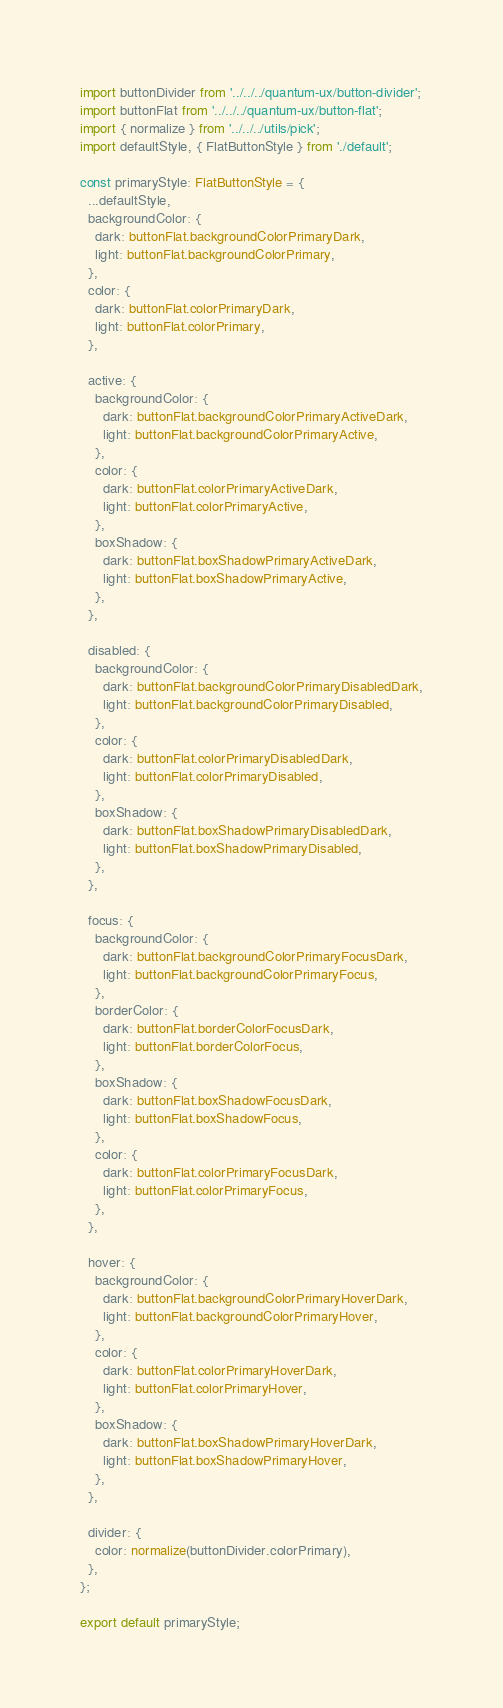<code> <loc_0><loc_0><loc_500><loc_500><_TypeScript_>import buttonDivider from '../../../quantum-ux/button-divider';
import buttonFlat from '../../../quantum-ux/button-flat';
import { normalize } from '../../../utils/pick';
import defaultStyle, { FlatButtonStyle } from './default';

const primaryStyle: FlatButtonStyle = {
  ...defaultStyle,
  backgroundColor: {
    dark: buttonFlat.backgroundColorPrimaryDark,
    light: buttonFlat.backgroundColorPrimary,
  },
  color: {
    dark: buttonFlat.colorPrimaryDark,
    light: buttonFlat.colorPrimary,
  },

  active: {
    backgroundColor: {
      dark: buttonFlat.backgroundColorPrimaryActiveDark,
      light: buttonFlat.backgroundColorPrimaryActive,
    },
    color: {
      dark: buttonFlat.colorPrimaryActiveDark,
      light: buttonFlat.colorPrimaryActive,
    },
    boxShadow: {
      dark: buttonFlat.boxShadowPrimaryActiveDark,
      light: buttonFlat.boxShadowPrimaryActive,
    },
  },

  disabled: {
    backgroundColor: {
      dark: buttonFlat.backgroundColorPrimaryDisabledDark,
      light: buttonFlat.backgroundColorPrimaryDisabled,
    },
    color: {
      dark: buttonFlat.colorPrimaryDisabledDark,
      light: buttonFlat.colorPrimaryDisabled,
    },
    boxShadow: {
      dark: buttonFlat.boxShadowPrimaryDisabledDark,
      light: buttonFlat.boxShadowPrimaryDisabled,
    },
  },

  focus: {
    backgroundColor: {
      dark: buttonFlat.backgroundColorPrimaryFocusDark,
      light: buttonFlat.backgroundColorPrimaryFocus,
    },
    borderColor: {
      dark: buttonFlat.borderColorFocusDark,
      light: buttonFlat.borderColorFocus,
    },
    boxShadow: {
      dark: buttonFlat.boxShadowFocusDark,
      light: buttonFlat.boxShadowFocus,
    },
    color: {
      dark: buttonFlat.colorPrimaryFocusDark,
      light: buttonFlat.colorPrimaryFocus,
    },
  },

  hover: {
    backgroundColor: {
      dark: buttonFlat.backgroundColorPrimaryHoverDark,
      light: buttonFlat.backgroundColorPrimaryHover,
    },
    color: {
      dark: buttonFlat.colorPrimaryHoverDark,
      light: buttonFlat.colorPrimaryHover,
    },
    boxShadow: {
      dark: buttonFlat.boxShadowPrimaryHoverDark,
      light: buttonFlat.boxShadowPrimaryHover,
    },
  },

  divider: {
    color: normalize(buttonDivider.colorPrimary),
  },
};

export default primaryStyle;
</code> 